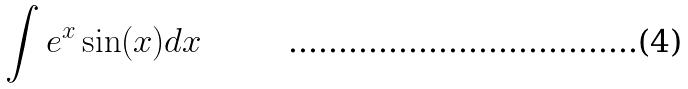Convert formula to latex. <formula><loc_0><loc_0><loc_500><loc_500>\int e ^ { x } \sin ( x ) d x</formula> 